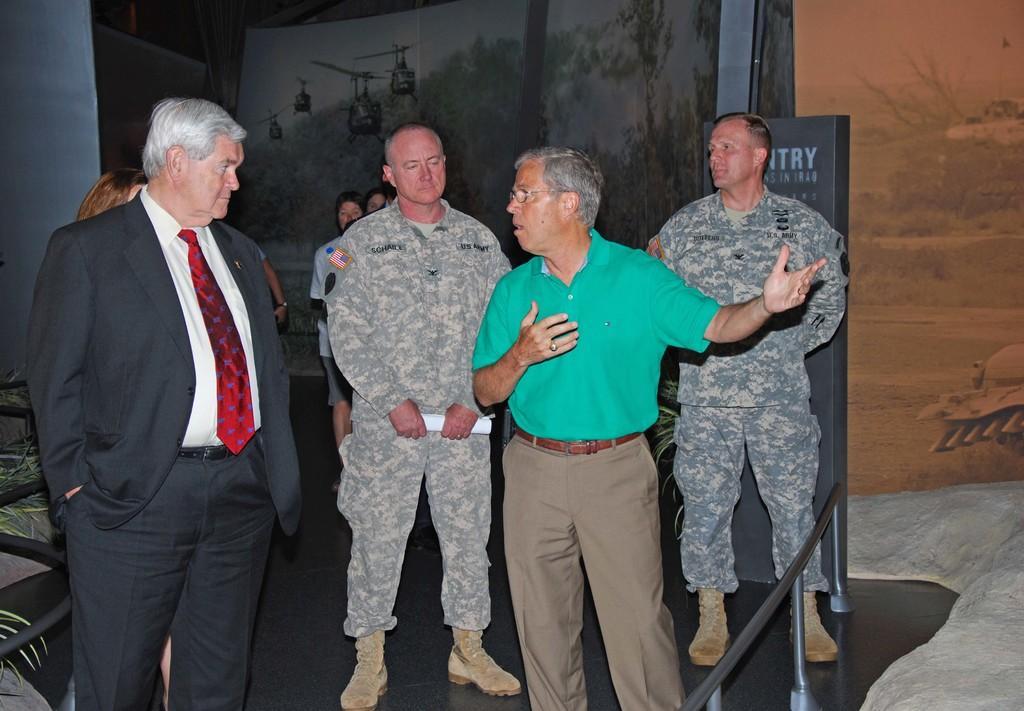Please provide a concise description of this image. In this image we can see a group of people standing. Behind the person we can see posters. On the right side of the image we can see a barrier. 